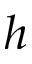<formula> <loc_0><loc_0><loc_500><loc_500>h</formula> 